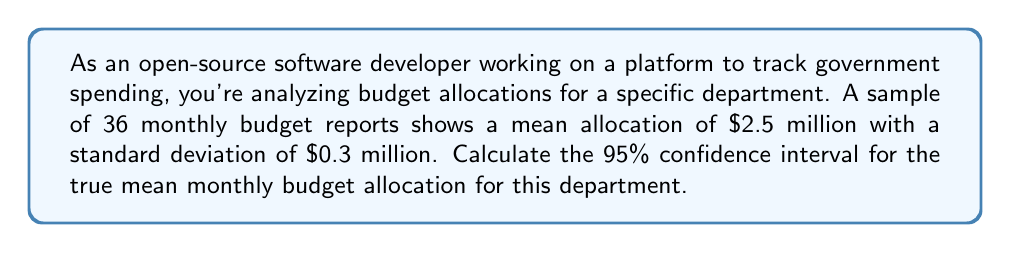Can you solve this math problem? To calculate the confidence interval, we'll follow these steps:

1) The formula for a confidence interval is:

   $$\bar{x} \pm t_{\alpha/2} \cdot \frac{s}{\sqrt{n}}$$

   Where:
   $\bar{x}$ is the sample mean
   $t_{\alpha/2}$ is the t-value for the desired confidence level
   $s$ is the sample standard deviation
   $n$ is the sample size

2) We're given:
   $\bar{x} = 2.5$ million
   $s = 0.3$ million
   $n = 36$
   Confidence level = 95% (so $\alpha = 0.05$)

3) For a 95% confidence interval with 35 degrees of freedom (n-1), the t-value is approximately 2.030 (from a t-table or calculator).

4) Plugging into the formula:

   $$2.5 \pm 2.030 \cdot \frac{0.3}{\sqrt{36}}$$

5) Simplify:
   $$2.5 \pm 2.030 \cdot \frac{0.3}{6}$$
   $$2.5 \pm 2.030 \cdot 0.05$$
   $$2.5 \pm 0.1015$$

6) Therefore, the confidence interval is:
   $$(2.3985, 2.6015)$$
Answer: (2.3985, 2.6015) million dollars 